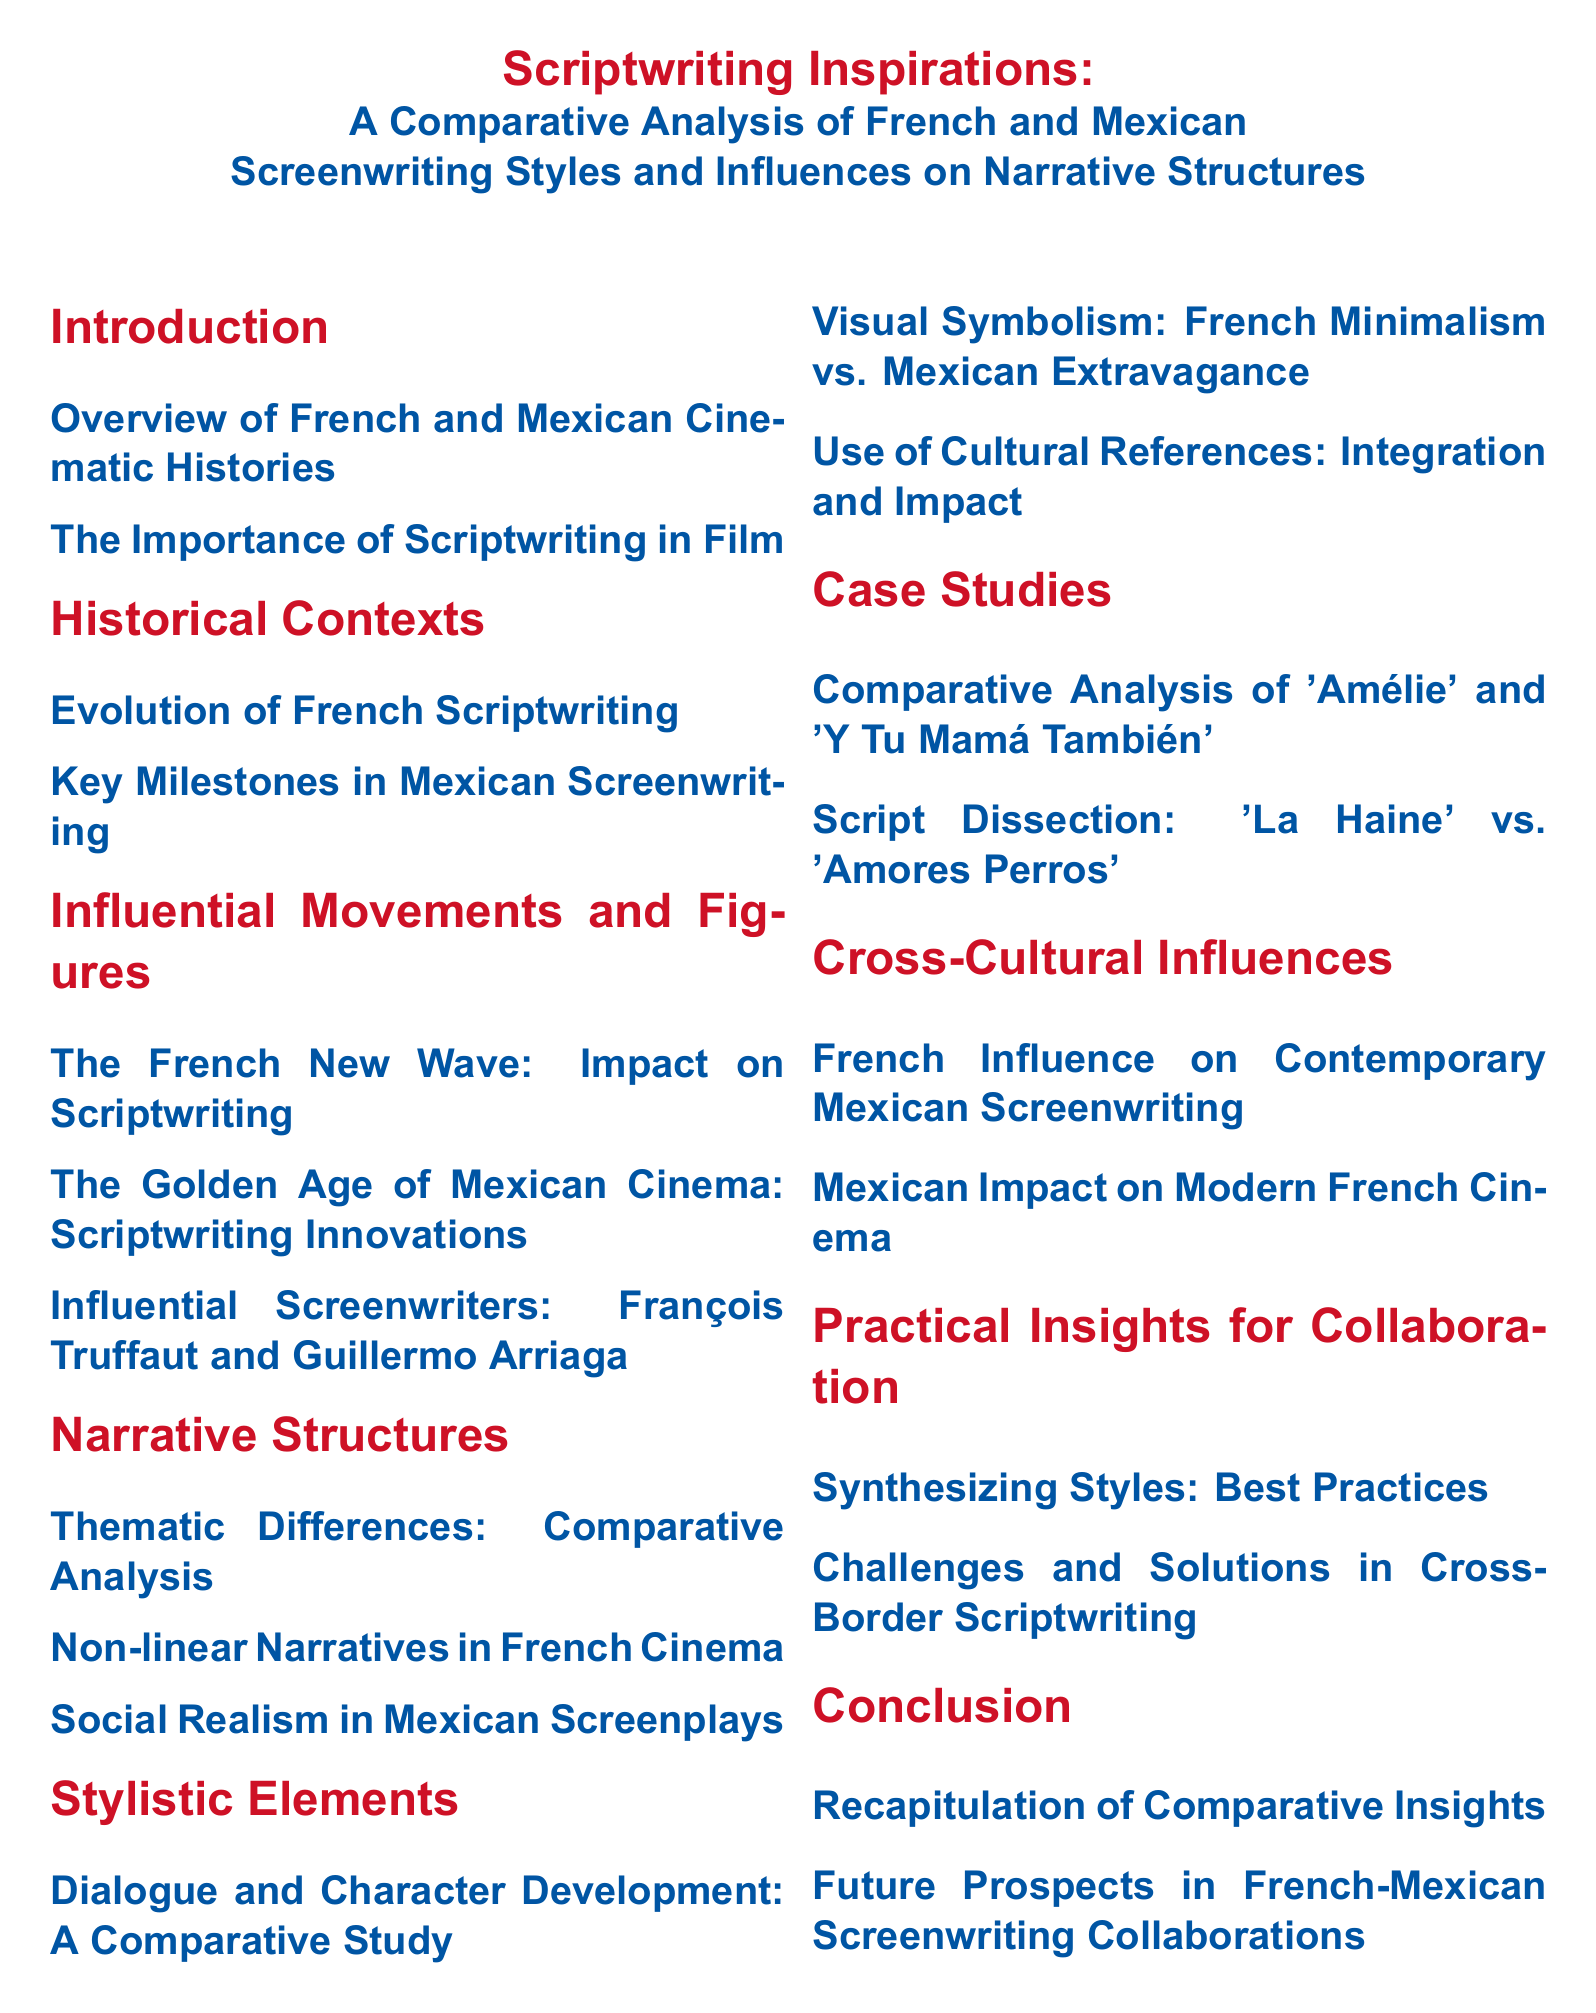What is the title of the document? The title of the document, found at the top of the rendered index, summarizes its content regarding scriptwriting inspirations.
Answer: Scriptwriting Inspirations: A Comparative Analysis of French and Mexican Screenwriting Styles and Influences on Narrative Structures Which section discusses the French New Wave? The document lists sections regarding influential movements, one of which explicitly mentions the French New Wave's impact on scriptwriting.
Answer: The French New Wave: Impact on Scriptwriting How many case studies are included in the document? The case studies section details the number of specific comparisons made, which can be counted in that part of the index.
Answer: 2 What color represents the Mexican section headings? The document uses color coding for different sections, indicated by the chosen color for Mexican section titles.
Answer: Mexican Red Who are the two influential screenwriters mentioned? This information summarizes a subsection where notable figures in screenwriting are listed, providing key names.
Answer: François Truffaut and Guillermo Arriaga What is the focus of the "Practical Insights for Collaboration" section? This section aims to provide guidance on integrating different styles and addressing challenges in scriptwriting, as described in its subsections.
Answer: Synthesizing Styles: Best Practices What narrative style is prominently featured in Mexican screenplays? The document specifies a thematic approach that is characteristic of many Mexican films, indicating its societal focus.
Answer: Social Realism What is the overall purpose of the document? The overarching aim is summarized in the introduction, which outlines the comparative analysis of two cinematic styles.
Answer: Comparative Analysis 